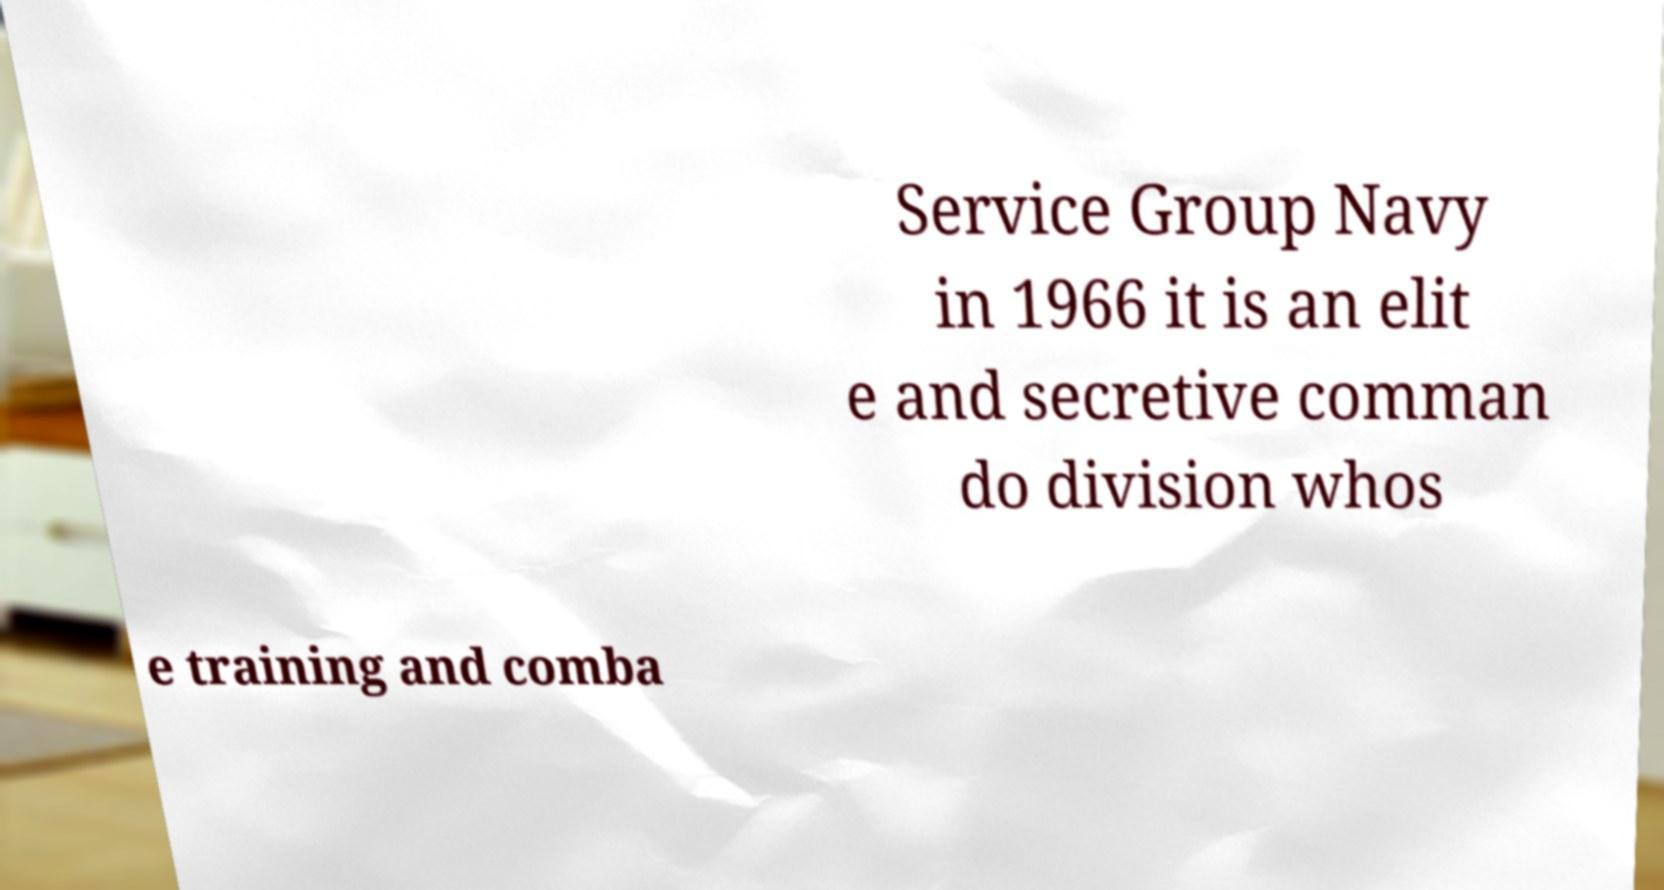Please read and relay the text visible in this image. What does it say? Service Group Navy in 1966 it is an elit e and secretive comman do division whos e training and comba 